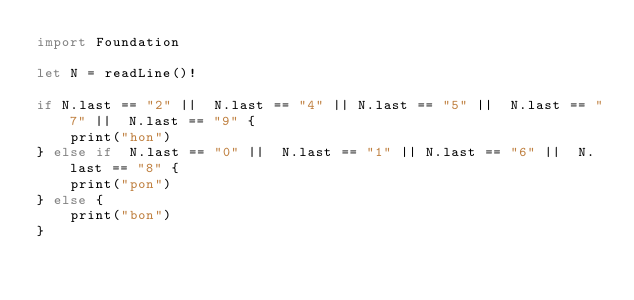<code> <loc_0><loc_0><loc_500><loc_500><_Swift_>import Foundation

let N = readLine()!

if N.last == "2" ||  N.last == "4" || N.last == "5" ||  N.last == "7" ||  N.last == "9" {
    print("hon")
} else if  N.last == "0" ||  N.last == "1" || N.last == "6" ||  N.last == "8" {
    print("pon")
} else {
    print("bon")
}</code> 